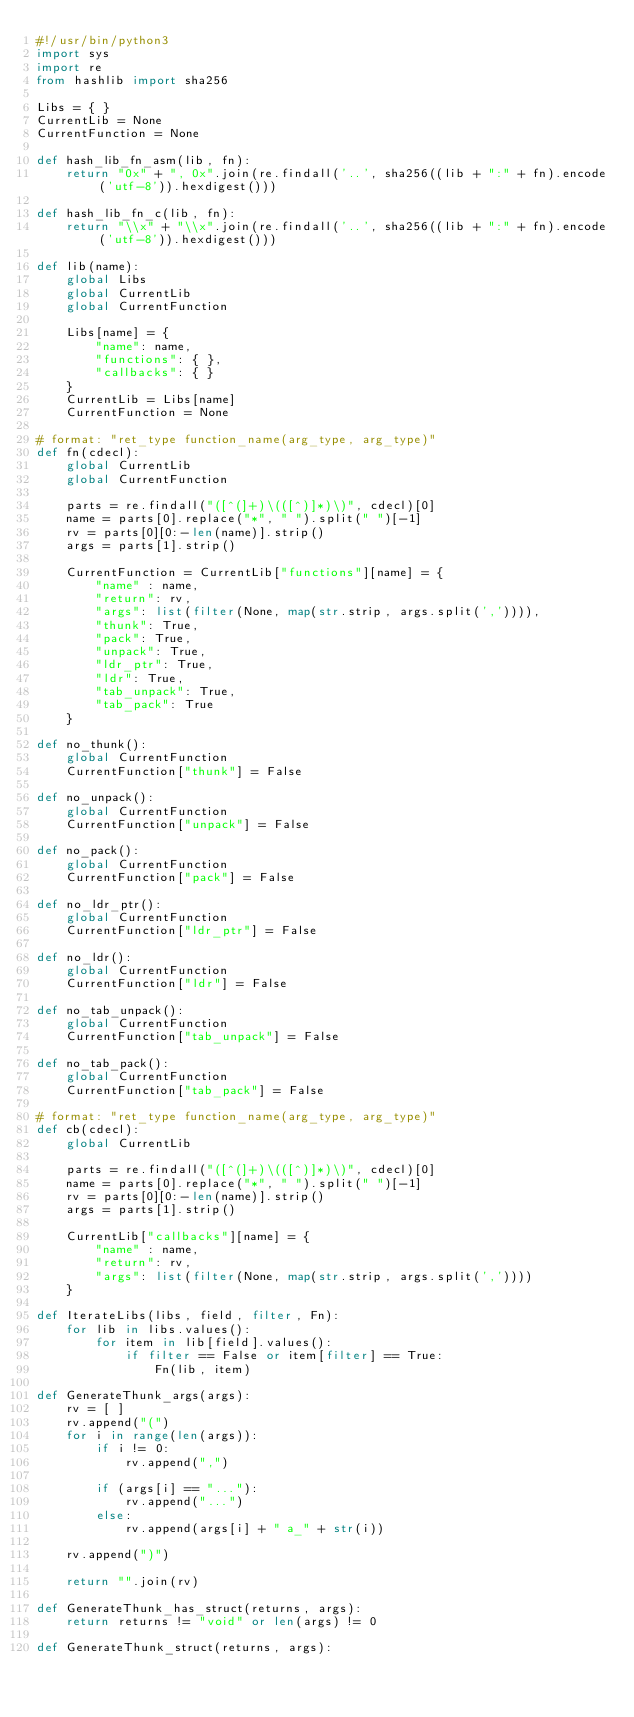Convert code to text. <code><loc_0><loc_0><loc_500><loc_500><_Python_>#!/usr/bin/python3
import sys
import re
from hashlib import sha256

Libs = { }
CurrentLib = None
CurrentFunction = None

def hash_lib_fn_asm(lib, fn):
    return "0x" + ", 0x".join(re.findall('..', sha256((lib + ":" + fn).encode('utf-8')).hexdigest()))

def hash_lib_fn_c(lib, fn):
    return "\\x" + "\\x".join(re.findall('..', sha256((lib + ":" + fn).encode('utf-8')).hexdigest()))

def lib(name):
    global Libs
    global CurrentLib
    global CurrentFunction

    Libs[name] = {
        "name": name,
        "functions": { },
        "callbacks": { }
    }
    CurrentLib = Libs[name]
    CurrentFunction = None

# format: "ret_type function_name(arg_type, arg_type)"
def fn(cdecl):
    global CurrentLib
    global CurrentFunction

    parts = re.findall("([^(]+)\(([^)]*)\)", cdecl)[0]
    name = parts[0].replace("*", " ").split(" ")[-1]
    rv = parts[0][0:-len(name)].strip()
    args = parts[1].strip()

    CurrentFunction = CurrentLib["functions"][name] = {
        "name" : name,
        "return": rv,
        "args": list(filter(None, map(str.strip, args.split(',')))),
        "thunk": True,
        "pack": True,
        "unpack": True,
        "ldr_ptr": True,
        "ldr": True,
        "tab_unpack": True,
        "tab_pack": True
    }

def no_thunk():
    global CurrentFunction
    CurrentFunction["thunk"] = False

def no_unpack():
    global CurrentFunction
    CurrentFunction["unpack"] = False

def no_pack():
    global CurrentFunction
    CurrentFunction["pack"] = False

def no_ldr_ptr():
    global CurrentFunction
    CurrentFunction["ldr_ptr"] = False

def no_ldr():
    global CurrentFunction
    CurrentFunction["ldr"] = False

def no_tab_unpack():
    global CurrentFunction
    CurrentFunction["tab_unpack"] = False

def no_tab_pack():
    global CurrentFunction
    CurrentFunction["tab_pack"] = False

# format: "ret_type function_name(arg_type, arg_type)"
def cb(cdecl):
    global CurrentLib

    parts = re.findall("([^(]+)\(([^)]*)\)", cdecl)[0]
    name = parts[0].replace("*", " ").split(" ")[-1]
    rv = parts[0][0:-len(name)].strip()
    args = parts[1].strip()

    CurrentLib["callbacks"][name] = {
        "name" : name,
        "return": rv,
        "args": list(filter(None, map(str.strip, args.split(','))))
    }

def IterateLibs(libs, field, filter, Fn):
    for lib in libs.values():
        for item in lib[field].values():
            if filter == False or item[filter] == True:
                Fn(lib, item)

def GenerateThunk_args(args):
    rv = [ ]
    rv.append("(")
    for i in range(len(args)):
        if i != 0:
            rv.append(",")

        if (args[i] == "..."):
            rv.append("...")
        else:
            rv.append(args[i] + " a_" + str(i))
            
    rv.append(")")

    return "".join(rv)

def GenerateThunk_has_struct(returns, args):
    return returns != "void" or len(args) != 0

def GenerateThunk_struct(returns, args):</code> 